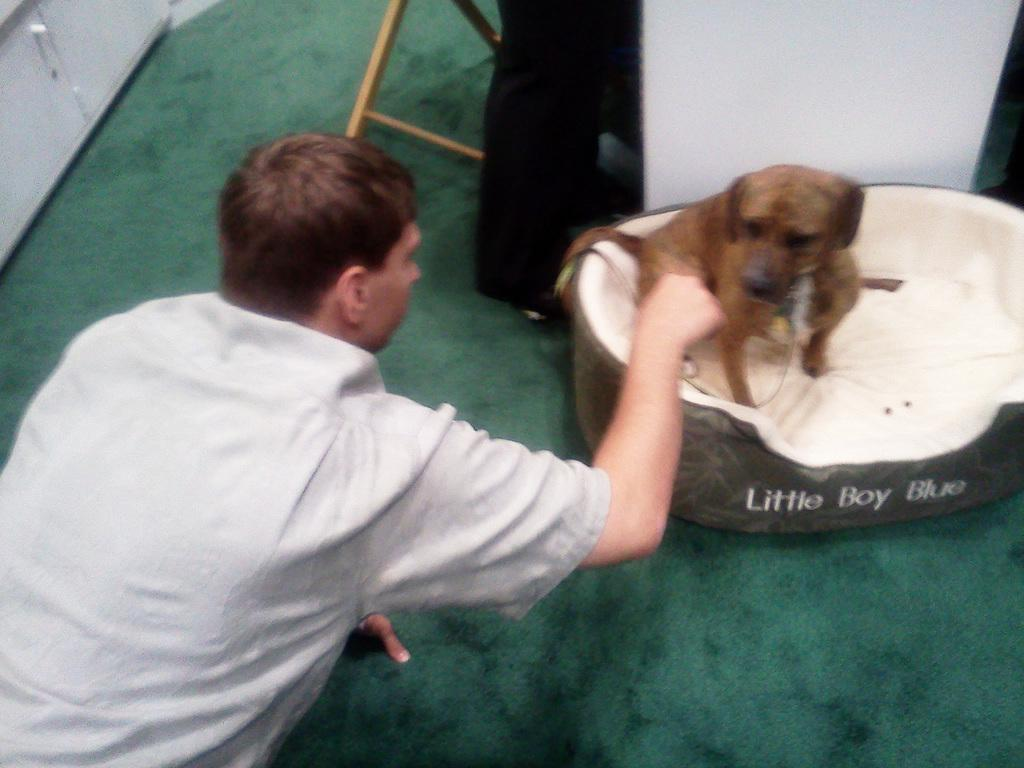Who is present in the image? There is a man in the image. What is the man doing in the image? The man is playing with a dog. Where is the dog located in the image? The dog is in a tub. What can be seen in the background of the image? There are cupboards in the background of the image. What type of flag is being waved by the dog in the image? There is no flag present in the image, and the dog is not waving anything. 